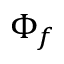<formula> <loc_0><loc_0><loc_500><loc_500>\Phi _ { f }</formula> 